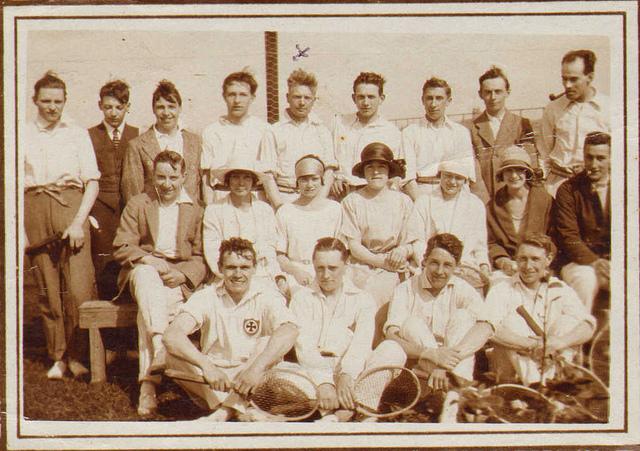Is the image in black and white?
Concise answer only. Yes. Is the front row a tennis team?
Short answer required. Yes. Was this picture taken in the 21 century?
Keep it brief. No. How many people are standing?
Write a very short answer. 9. How many people are in the picture?
Short answer required. 20. Is this a co-ed team?
Answer briefly. Yes. What sort of club or team is represented?
Keep it brief. Tennis. What are the men holding?
Quick response, please. Tennis rackets. 